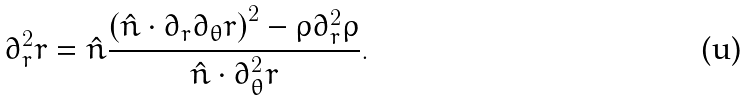<formula> <loc_0><loc_0><loc_500><loc_500>\partial _ { r } ^ { 2 } r = \hat { n } \frac { \left ( \hat { n } \cdot \partial _ { r } \partial _ { \theta } r \right ) ^ { 2 } - \rho \partial _ { r } ^ { 2 } \rho } { \hat { n } \cdot \partial _ { \theta } ^ { 2 } r } .</formula> 